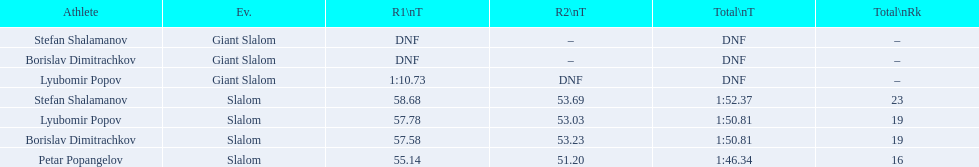Which event is the giant slalom? Giant Slalom, Giant Slalom, Giant Slalom. Which one is lyubomir popov? Lyubomir Popov. What is race 1 tim? 1:10.73. 